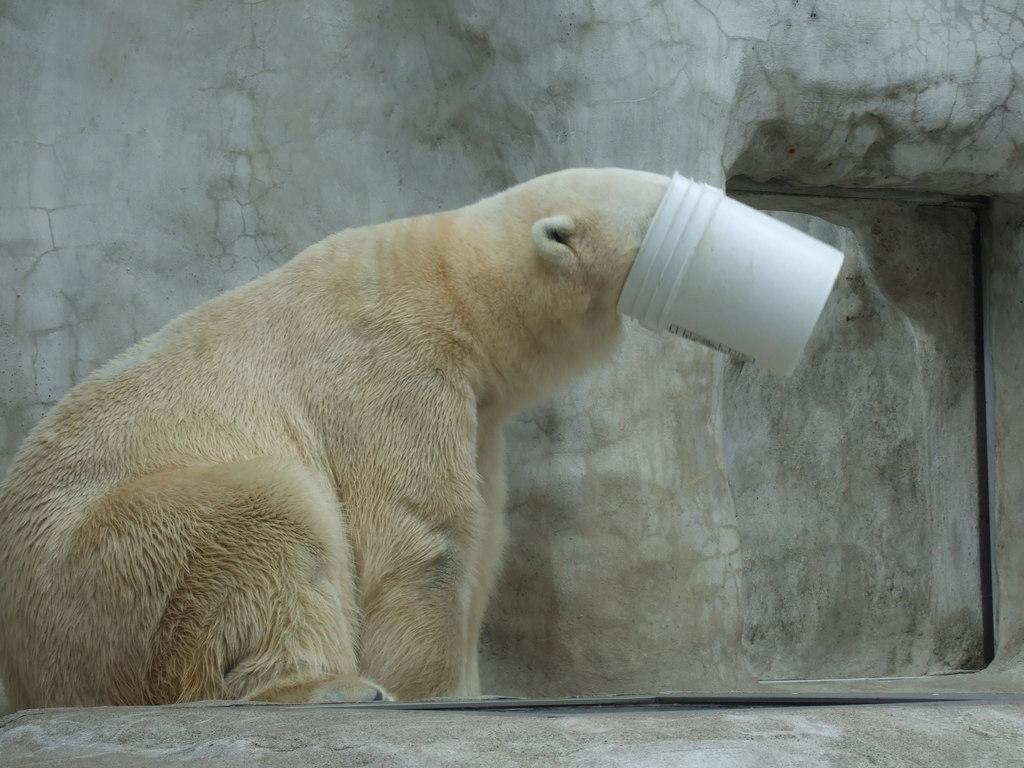What animal is the main subject of the image? There is a polar bear in the image. Where is the polar bear located in the image? The polar bear is on the left side of the image. What is the polar bear doing in the image? The polar bear's face is stuck in a bucket. What can be seen in the background of the image? There is a wall in the background of the image. What type of wine is being served at the committee meeting in the image? There is no committee meeting or wine present in the image; it features a polar bear with its face stuck in a bucket. 